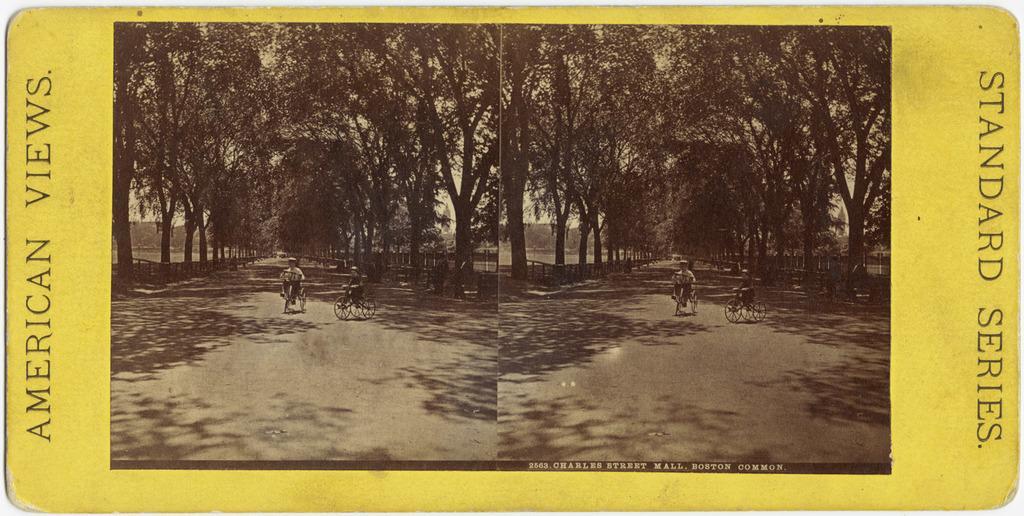Could you give a brief overview of what you see in this image? This is an edited image. It looks like a card with the pictures of the trees and two persons riding tricycles on the road. On the left and right side of the image, I can see the letters on the card. 